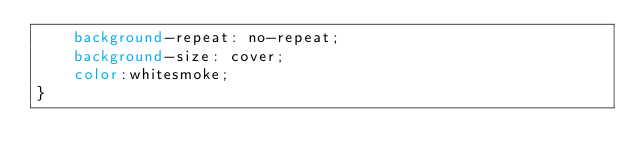<code> <loc_0><loc_0><loc_500><loc_500><_CSS_>    background-repeat: no-repeat;
    background-size: cover;
    color:whitesmoke;
}</code> 